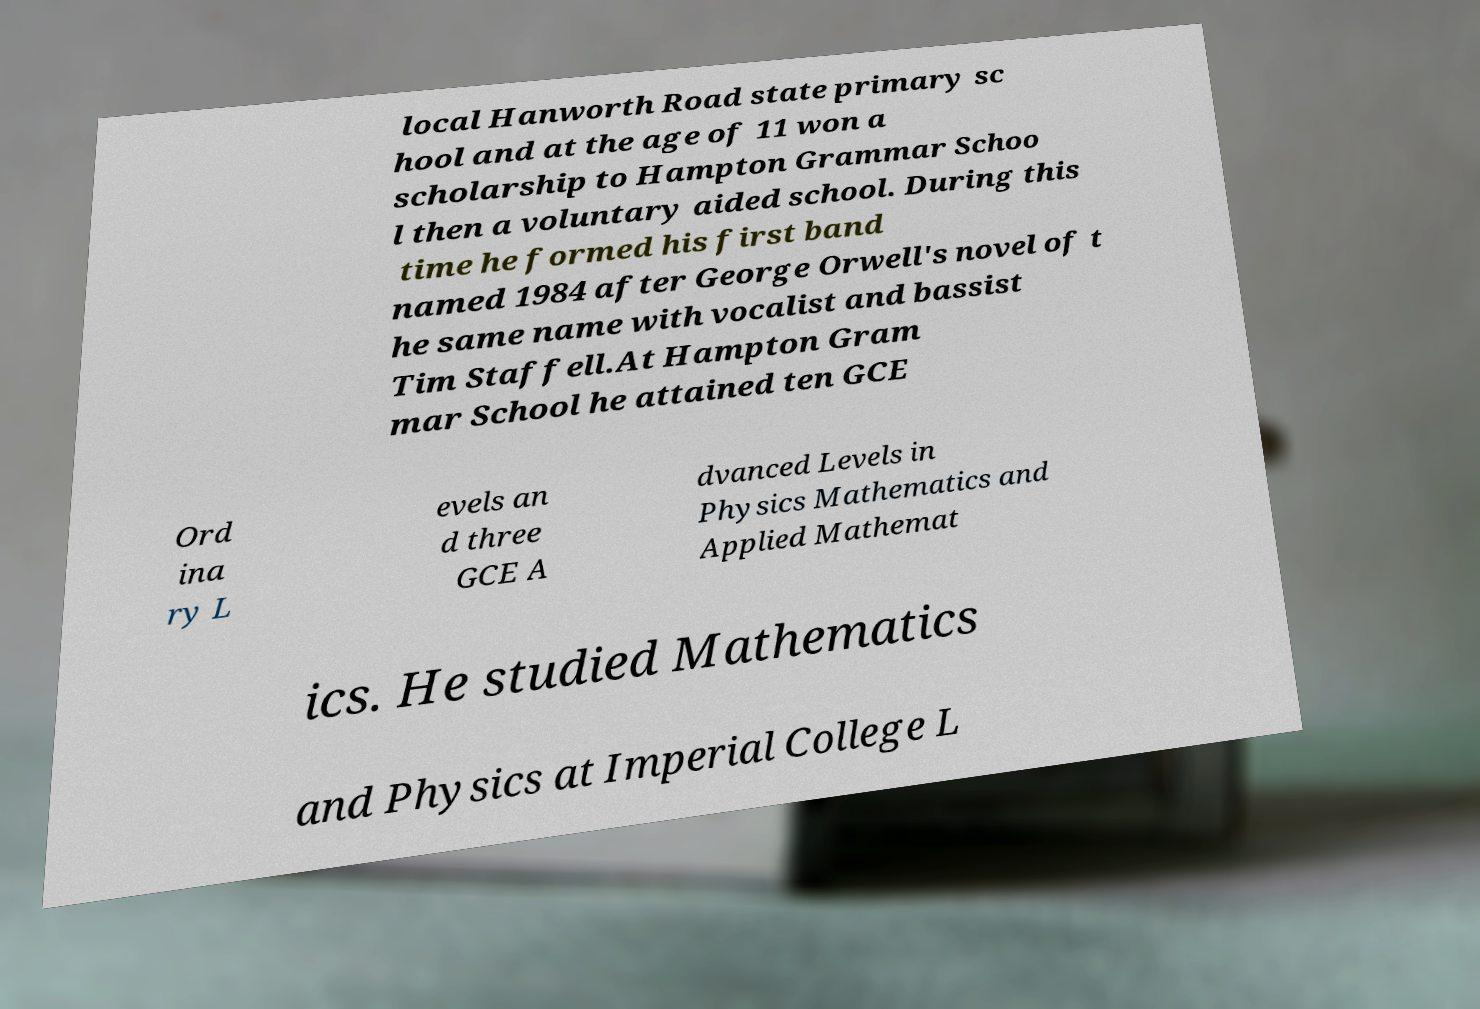Could you extract and type out the text from this image? local Hanworth Road state primary sc hool and at the age of 11 won a scholarship to Hampton Grammar Schoo l then a voluntary aided school. During this time he formed his first band named 1984 after George Orwell's novel of t he same name with vocalist and bassist Tim Staffell.At Hampton Gram mar School he attained ten GCE Ord ina ry L evels an d three GCE A dvanced Levels in Physics Mathematics and Applied Mathemat ics. He studied Mathematics and Physics at Imperial College L 